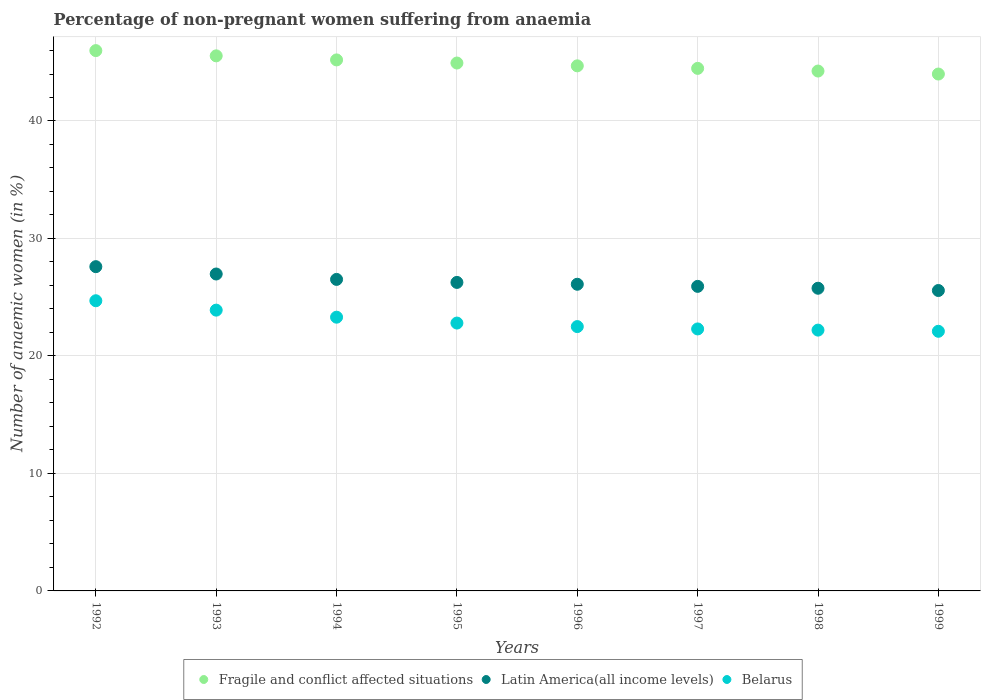Is the number of dotlines equal to the number of legend labels?
Keep it short and to the point. Yes. What is the percentage of non-pregnant women suffering from anaemia in Fragile and conflict affected situations in 1993?
Your response must be concise. 45.54. Across all years, what is the maximum percentage of non-pregnant women suffering from anaemia in Latin America(all income levels)?
Your response must be concise. 27.6. Across all years, what is the minimum percentage of non-pregnant women suffering from anaemia in Belarus?
Offer a terse response. 22.1. In which year was the percentage of non-pregnant women suffering from anaemia in Latin America(all income levels) maximum?
Ensure brevity in your answer.  1992. What is the total percentage of non-pregnant women suffering from anaemia in Latin America(all income levels) in the graph?
Give a very brief answer. 210.71. What is the difference between the percentage of non-pregnant women suffering from anaemia in Belarus in 1997 and that in 1999?
Make the answer very short. 0.2. What is the difference between the percentage of non-pregnant women suffering from anaemia in Belarus in 1998 and the percentage of non-pregnant women suffering from anaemia in Fragile and conflict affected situations in 1996?
Your response must be concise. -22.49. What is the average percentage of non-pregnant women suffering from anaemia in Latin America(all income levels) per year?
Offer a very short reply. 26.34. In the year 1998, what is the difference between the percentage of non-pregnant women suffering from anaemia in Belarus and percentage of non-pregnant women suffering from anaemia in Fragile and conflict affected situations?
Provide a succinct answer. -22.05. What is the ratio of the percentage of non-pregnant women suffering from anaemia in Latin America(all income levels) in 1993 to that in 1996?
Keep it short and to the point. 1.03. Is the percentage of non-pregnant women suffering from anaemia in Fragile and conflict affected situations in 1993 less than that in 1997?
Your answer should be compact. No. What is the difference between the highest and the second highest percentage of non-pregnant women suffering from anaemia in Belarus?
Keep it short and to the point. 0.8. What is the difference between the highest and the lowest percentage of non-pregnant women suffering from anaemia in Belarus?
Keep it short and to the point. 2.6. Is the sum of the percentage of non-pregnant women suffering from anaemia in Belarus in 1992 and 1996 greater than the maximum percentage of non-pregnant women suffering from anaemia in Fragile and conflict affected situations across all years?
Provide a succinct answer. Yes. Is it the case that in every year, the sum of the percentage of non-pregnant women suffering from anaemia in Belarus and percentage of non-pregnant women suffering from anaemia in Fragile and conflict affected situations  is greater than the percentage of non-pregnant women suffering from anaemia in Latin America(all income levels)?
Ensure brevity in your answer.  Yes. Is the percentage of non-pregnant women suffering from anaemia in Belarus strictly less than the percentage of non-pregnant women suffering from anaemia in Fragile and conflict affected situations over the years?
Make the answer very short. Yes. How many dotlines are there?
Make the answer very short. 3. How many years are there in the graph?
Keep it short and to the point. 8. What is the difference between two consecutive major ticks on the Y-axis?
Your answer should be very brief. 10. Does the graph contain any zero values?
Keep it short and to the point. No. Does the graph contain grids?
Give a very brief answer. Yes. Where does the legend appear in the graph?
Make the answer very short. Bottom center. How many legend labels are there?
Provide a succinct answer. 3. What is the title of the graph?
Ensure brevity in your answer.  Percentage of non-pregnant women suffering from anaemia. What is the label or title of the Y-axis?
Your answer should be compact. Number of anaemic women (in %). What is the Number of anaemic women (in %) in Fragile and conflict affected situations in 1992?
Offer a very short reply. 45.99. What is the Number of anaemic women (in %) of Latin America(all income levels) in 1992?
Keep it short and to the point. 27.6. What is the Number of anaemic women (in %) of Belarus in 1992?
Your answer should be very brief. 24.7. What is the Number of anaemic women (in %) of Fragile and conflict affected situations in 1993?
Offer a terse response. 45.54. What is the Number of anaemic women (in %) in Latin America(all income levels) in 1993?
Provide a succinct answer. 26.98. What is the Number of anaemic women (in %) of Belarus in 1993?
Offer a terse response. 23.9. What is the Number of anaemic women (in %) of Fragile and conflict affected situations in 1994?
Provide a short and direct response. 45.2. What is the Number of anaemic women (in %) of Latin America(all income levels) in 1994?
Give a very brief answer. 26.52. What is the Number of anaemic women (in %) in Belarus in 1994?
Provide a succinct answer. 23.3. What is the Number of anaemic women (in %) in Fragile and conflict affected situations in 1995?
Make the answer very short. 44.93. What is the Number of anaemic women (in %) in Latin America(all income levels) in 1995?
Give a very brief answer. 26.26. What is the Number of anaemic women (in %) in Belarus in 1995?
Keep it short and to the point. 22.8. What is the Number of anaemic women (in %) of Fragile and conflict affected situations in 1996?
Ensure brevity in your answer.  44.69. What is the Number of anaemic women (in %) in Latin America(all income levels) in 1996?
Your response must be concise. 26.1. What is the Number of anaemic women (in %) of Belarus in 1996?
Your response must be concise. 22.5. What is the Number of anaemic women (in %) in Fragile and conflict affected situations in 1997?
Ensure brevity in your answer.  44.48. What is the Number of anaemic women (in %) of Latin America(all income levels) in 1997?
Your answer should be compact. 25.92. What is the Number of anaemic women (in %) in Belarus in 1997?
Your response must be concise. 22.3. What is the Number of anaemic women (in %) in Fragile and conflict affected situations in 1998?
Your answer should be compact. 44.25. What is the Number of anaemic women (in %) in Latin America(all income levels) in 1998?
Offer a very short reply. 25.76. What is the Number of anaemic women (in %) of Fragile and conflict affected situations in 1999?
Offer a very short reply. 44. What is the Number of anaemic women (in %) of Latin America(all income levels) in 1999?
Make the answer very short. 25.57. What is the Number of anaemic women (in %) of Belarus in 1999?
Make the answer very short. 22.1. Across all years, what is the maximum Number of anaemic women (in %) in Fragile and conflict affected situations?
Your answer should be very brief. 45.99. Across all years, what is the maximum Number of anaemic women (in %) in Latin America(all income levels)?
Offer a very short reply. 27.6. Across all years, what is the maximum Number of anaemic women (in %) of Belarus?
Provide a succinct answer. 24.7. Across all years, what is the minimum Number of anaemic women (in %) of Fragile and conflict affected situations?
Provide a succinct answer. 44. Across all years, what is the minimum Number of anaemic women (in %) in Latin America(all income levels)?
Make the answer very short. 25.57. Across all years, what is the minimum Number of anaemic women (in %) of Belarus?
Provide a short and direct response. 22.1. What is the total Number of anaemic women (in %) in Fragile and conflict affected situations in the graph?
Your answer should be very brief. 359.09. What is the total Number of anaemic women (in %) of Latin America(all income levels) in the graph?
Provide a short and direct response. 210.71. What is the total Number of anaemic women (in %) in Belarus in the graph?
Provide a succinct answer. 183.8. What is the difference between the Number of anaemic women (in %) of Fragile and conflict affected situations in 1992 and that in 1993?
Offer a terse response. 0.45. What is the difference between the Number of anaemic women (in %) of Latin America(all income levels) in 1992 and that in 1993?
Offer a terse response. 0.63. What is the difference between the Number of anaemic women (in %) in Fragile and conflict affected situations in 1992 and that in 1994?
Give a very brief answer. 0.79. What is the difference between the Number of anaemic women (in %) in Latin America(all income levels) in 1992 and that in 1994?
Your response must be concise. 1.08. What is the difference between the Number of anaemic women (in %) of Belarus in 1992 and that in 1994?
Offer a terse response. 1.4. What is the difference between the Number of anaemic women (in %) in Fragile and conflict affected situations in 1992 and that in 1995?
Ensure brevity in your answer.  1.06. What is the difference between the Number of anaemic women (in %) of Latin America(all income levels) in 1992 and that in 1995?
Your answer should be very brief. 1.34. What is the difference between the Number of anaemic women (in %) of Fragile and conflict affected situations in 1992 and that in 1996?
Provide a short and direct response. 1.3. What is the difference between the Number of anaemic women (in %) in Latin America(all income levels) in 1992 and that in 1996?
Provide a succinct answer. 1.5. What is the difference between the Number of anaemic women (in %) of Belarus in 1992 and that in 1996?
Offer a terse response. 2.2. What is the difference between the Number of anaemic women (in %) of Fragile and conflict affected situations in 1992 and that in 1997?
Ensure brevity in your answer.  1.51. What is the difference between the Number of anaemic women (in %) in Latin America(all income levels) in 1992 and that in 1997?
Ensure brevity in your answer.  1.68. What is the difference between the Number of anaemic women (in %) of Belarus in 1992 and that in 1997?
Keep it short and to the point. 2.4. What is the difference between the Number of anaemic women (in %) in Fragile and conflict affected situations in 1992 and that in 1998?
Your answer should be compact. 1.74. What is the difference between the Number of anaemic women (in %) in Latin America(all income levels) in 1992 and that in 1998?
Give a very brief answer. 1.84. What is the difference between the Number of anaemic women (in %) in Fragile and conflict affected situations in 1992 and that in 1999?
Provide a short and direct response. 1.99. What is the difference between the Number of anaemic women (in %) in Latin America(all income levels) in 1992 and that in 1999?
Your response must be concise. 2.03. What is the difference between the Number of anaemic women (in %) of Belarus in 1992 and that in 1999?
Give a very brief answer. 2.6. What is the difference between the Number of anaemic women (in %) of Fragile and conflict affected situations in 1993 and that in 1994?
Ensure brevity in your answer.  0.35. What is the difference between the Number of anaemic women (in %) in Latin America(all income levels) in 1993 and that in 1994?
Your response must be concise. 0.46. What is the difference between the Number of anaemic women (in %) of Fragile and conflict affected situations in 1993 and that in 1995?
Make the answer very short. 0.61. What is the difference between the Number of anaemic women (in %) in Latin America(all income levels) in 1993 and that in 1995?
Keep it short and to the point. 0.72. What is the difference between the Number of anaemic women (in %) in Fragile and conflict affected situations in 1993 and that in 1996?
Keep it short and to the point. 0.85. What is the difference between the Number of anaemic women (in %) in Latin America(all income levels) in 1993 and that in 1996?
Ensure brevity in your answer.  0.87. What is the difference between the Number of anaemic women (in %) in Fragile and conflict affected situations in 1993 and that in 1997?
Ensure brevity in your answer.  1.07. What is the difference between the Number of anaemic women (in %) in Latin America(all income levels) in 1993 and that in 1997?
Provide a succinct answer. 1.05. What is the difference between the Number of anaemic women (in %) of Belarus in 1993 and that in 1997?
Your answer should be very brief. 1.6. What is the difference between the Number of anaemic women (in %) in Fragile and conflict affected situations in 1993 and that in 1998?
Keep it short and to the point. 1.29. What is the difference between the Number of anaemic women (in %) of Latin America(all income levels) in 1993 and that in 1998?
Keep it short and to the point. 1.21. What is the difference between the Number of anaemic women (in %) of Fragile and conflict affected situations in 1993 and that in 1999?
Your answer should be compact. 1.55. What is the difference between the Number of anaemic women (in %) in Latin America(all income levels) in 1993 and that in 1999?
Your answer should be compact. 1.41. What is the difference between the Number of anaemic women (in %) of Belarus in 1993 and that in 1999?
Your response must be concise. 1.8. What is the difference between the Number of anaemic women (in %) in Fragile and conflict affected situations in 1994 and that in 1995?
Keep it short and to the point. 0.27. What is the difference between the Number of anaemic women (in %) in Latin America(all income levels) in 1994 and that in 1995?
Your answer should be very brief. 0.26. What is the difference between the Number of anaemic women (in %) of Belarus in 1994 and that in 1995?
Offer a very short reply. 0.5. What is the difference between the Number of anaemic women (in %) in Fragile and conflict affected situations in 1994 and that in 1996?
Keep it short and to the point. 0.51. What is the difference between the Number of anaemic women (in %) of Latin America(all income levels) in 1994 and that in 1996?
Your answer should be compact. 0.41. What is the difference between the Number of anaemic women (in %) in Fragile and conflict affected situations in 1994 and that in 1997?
Keep it short and to the point. 0.72. What is the difference between the Number of anaemic women (in %) of Latin America(all income levels) in 1994 and that in 1997?
Your answer should be compact. 0.59. What is the difference between the Number of anaemic women (in %) in Fragile and conflict affected situations in 1994 and that in 1998?
Your answer should be compact. 0.95. What is the difference between the Number of anaemic women (in %) of Latin America(all income levels) in 1994 and that in 1998?
Provide a short and direct response. 0.75. What is the difference between the Number of anaemic women (in %) of Fragile and conflict affected situations in 1994 and that in 1999?
Your response must be concise. 1.2. What is the difference between the Number of anaemic women (in %) of Latin America(all income levels) in 1994 and that in 1999?
Give a very brief answer. 0.95. What is the difference between the Number of anaemic women (in %) in Belarus in 1994 and that in 1999?
Provide a short and direct response. 1.2. What is the difference between the Number of anaemic women (in %) of Fragile and conflict affected situations in 1995 and that in 1996?
Make the answer very short. 0.24. What is the difference between the Number of anaemic women (in %) of Latin America(all income levels) in 1995 and that in 1996?
Offer a very short reply. 0.16. What is the difference between the Number of anaemic women (in %) of Belarus in 1995 and that in 1996?
Offer a very short reply. 0.3. What is the difference between the Number of anaemic women (in %) of Fragile and conflict affected situations in 1995 and that in 1997?
Your answer should be very brief. 0.45. What is the difference between the Number of anaemic women (in %) of Latin America(all income levels) in 1995 and that in 1997?
Offer a very short reply. 0.34. What is the difference between the Number of anaemic women (in %) in Belarus in 1995 and that in 1997?
Provide a succinct answer. 0.5. What is the difference between the Number of anaemic women (in %) in Fragile and conflict affected situations in 1995 and that in 1998?
Your answer should be compact. 0.68. What is the difference between the Number of anaemic women (in %) of Latin America(all income levels) in 1995 and that in 1998?
Your response must be concise. 0.5. What is the difference between the Number of anaemic women (in %) of Belarus in 1995 and that in 1998?
Offer a terse response. 0.6. What is the difference between the Number of anaemic women (in %) of Fragile and conflict affected situations in 1995 and that in 1999?
Make the answer very short. 0.94. What is the difference between the Number of anaemic women (in %) of Latin America(all income levels) in 1995 and that in 1999?
Your response must be concise. 0.69. What is the difference between the Number of anaemic women (in %) of Belarus in 1995 and that in 1999?
Offer a terse response. 0.7. What is the difference between the Number of anaemic women (in %) in Fragile and conflict affected situations in 1996 and that in 1997?
Keep it short and to the point. 0.21. What is the difference between the Number of anaemic women (in %) in Latin America(all income levels) in 1996 and that in 1997?
Make the answer very short. 0.18. What is the difference between the Number of anaemic women (in %) in Belarus in 1996 and that in 1997?
Provide a short and direct response. 0.2. What is the difference between the Number of anaemic women (in %) in Fragile and conflict affected situations in 1996 and that in 1998?
Give a very brief answer. 0.44. What is the difference between the Number of anaemic women (in %) of Latin America(all income levels) in 1996 and that in 1998?
Ensure brevity in your answer.  0.34. What is the difference between the Number of anaemic women (in %) in Belarus in 1996 and that in 1998?
Provide a succinct answer. 0.3. What is the difference between the Number of anaemic women (in %) in Fragile and conflict affected situations in 1996 and that in 1999?
Keep it short and to the point. 0.7. What is the difference between the Number of anaemic women (in %) in Latin America(all income levels) in 1996 and that in 1999?
Your answer should be very brief. 0.53. What is the difference between the Number of anaemic women (in %) in Fragile and conflict affected situations in 1997 and that in 1998?
Ensure brevity in your answer.  0.23. What is the difference between the Number of anaemic women (in %) of Latin America(all income levels) in 1997 and that in 1998?
Your response must be concise. 0.16. What is the difference between the Number of anaemic women (in %) of Fragile and conflict affected situations in 1997 and that in 1999?
Ensure brevity in your answer.  0.48. What is the difference between the Number of anaemic women (in %) of Latin America(all income levels) in 1997 and that in 1999?
Make the answer very short. 0.35. What is the difference between the Number of anaemic women (in %) in Fragile and conflict affected situations in 1998 and that in 1999?
Keep it short and to the point. 0.25. What is the difference between the Number of anaemic women (in %) in Latin America(all income levels) in 1998 and that in 1999?
Ensure brevity in your answer.  0.19. What is the difference between the Number of anaemic women (in %) in Belarus in 1998 and that in 1999?
Provide a short and direct response. 0.1. What is the difference between the Number of anaemic women (in %) in Fragile and conflict affected situations in 1992 and the Number of anaemic women (in %) in Latin America(all income levels) in 1993?
Offer a very short reply. 19.02. What is the difference between the Number of anaemic women (in %) of Fragile and conflict affected situations in 1992 and the Number of anaemic women (in %) of Belarus in 1993?
Offer a terse response. 22.09. What is the difference between the Number of anaemic women (in %) of Latin America(all income levels) in 1992 and the Number of anaemic women (in %) of Belarus in 1993?
Your answer should be compact. 3.7. What is the difference between the Number of anaemic women (in %) in Fragile and conflict affected situations in 1992 and the Number of anaemic women (in %) in Latin America(all income levels) in 1994?
Provide a short and direct response. 19.47. What is the difference between the Number of anaemic women (in %) in Fragile and conflict affected situations in 1992 and the Number of anaemic women (in %) in Belarus in 1994?
Your response must be concise. 22.69. What is the difference between the Number of anaemic women (in %) of Latin America(all income levels) in 1992 and the Number of anaemic women (in %) of Belarus in 1994?
Ensure brevity in your answer.  4.3. What is the difference between the Number of anaemic women (in %) of Fragile and conflict affected situations in 1992 and the Number of anaemic women (in %) of Latin America(all income levels) in 1995?
Your answer should be compact. 19.73. What is the difference between the Number of anaemic women (in %) of Fragile and conflict affected situations in 1992 and the Number of anaemic women (in %) of Belarus in 1995?
Make the answer very short. 23.19. What is the difference between the Number of anaemic women (in %) of Latin America(all income levels) in 1992 and the Number of anaemic women (in %) of Belarus in 1995?
Keep it short and to the point. 4.8. What is the difference between the Number of anaemic women (in %) in Fragile and conflict affected situations in 1992 and the Number of anaemic women (in %) in Latin America(all income levels) in 1996?
Make the answer very short. 19.89. What is the difference between the Number of anaemic women (in %) in Fragile and conflict affected situations in 1992 and the Number of anaemic women (in %) in Belarus in 1996?
Give a very brief answer. 23.49. What is the difference between the Number of anaemic women (in %) of Latin America(all income levels) in 1992 and the Number of anaemic women (in %) of Belarus in 1996?
Your response must be concise. 5.1. What is the difference between the Number of anaemic women (in %) of Fragile and conflict affected situations in 1992 and the Number of anaemic women (in %) of Latin America(all income levels) in 1997?
Make the answer very short. 20.07. What is the difference between the Number of anaemic women (in %) in Fragile and conflict affected situations in 1992 and the Number of anaemic women (in %) in Belarus in 1997?
Keep it short and to the point. 23.69. What is the difference between the Number of anaemic women (in %) in Latin America(all income levels) in 1992 and the Number of anaemic women (in %) in Belarus in 1997?
Give a very brief answer. 5.3. What is the difference between the Number of anaemic women (in %) of Fragile and conflict affected situations in 1992 and the Number of anaemic women (in %) of Latin America(all income levels) in 1998?
Your answer should be compact. 20.23. What is the difference between the Number of anaemic women (in %) in Fragile and conflict affected situations in 1992 and the Number of anaemic women (in %) in Belarus in 1998?
Keep it short and to the point. 23.79. What is the difference between the Number of anaemic women (in %) in Latin America(all income levels) in 1992 and the Number of anaemic women (in %) in Belarus in 1998?
Offer a very short reply. 5.4. What is the difference between the Number of anaemic women (in %) of Fragile and conflict affected situations in 1992 and the Number of anaemic women (in %) of Latin America(all income levels) in 1999?
Your response must be concise. 20.42. What is the difference between the Number of anaemic women (in %) of Fragile and conflict affected situations in 1992 and the Number of anaemic women (in %) of Belarus in 1999?
Make the answer very short. 23.89. What is the difference between the Number of anaemic women (in %) of Latin America(all income levels) in 1992 and the Number of anaemic women (in %) of Belarus in 1999?
Give a very brief answer. 5.5. What is the difference between the Number of anaemic women (in %) of Fragile and conflict affected situations in 1993 and the Number of anaemic women (in %) of Latin America(all income levels) in 1994?
Keep it short and to the point. 19.03. What is the difference between the Number of anaemic women (in %) in Fragile and conflict affected situations in 1993 and the Number of anaemic women (in %) in Belarus in 1994?
Offer a very short reply. 22.24. What is the difference between the Number of anaemic women (in %) in Latin America(all income levels) in 1993 and the Number of anaemic women (in %) in Belarus in 1994?
Provide a short and direct response. 3.68. What is the difference between the Number of anaemic women (in %) of Fragile and conflict affected situations in 1993 and the Number of anaemic women (in %) of Latin America(all income levels) in 1995?
Keep it short and to the point. 19.29. What is the difference between the Number of anaemic women (in %) in Fragile and conflict affected situations in 1993 and the Number of anaemic women (in %) in Belarus in 1995?
Your answer should be very brief. 22.74. What is the difference between the Number of anaemic women (in %) of Latin America(all income levels) in 1993 and the Number of anaemic women (in %) of Belarus in 1995?
Provide a succinct answer. 4.18. What is the difference between the Number of anaemic women (in %) of Fragile and conflict affected situations in 1993 and the Number of anaemic women (in %) of Latin America(all income levels) in 1996?
Give a very brief answer. 19.44. What is the difference between the Number of anaemic women (in %) of Fragile and conflict affected situations in 1993 and the Number of anaemic women (in %) of Belarus in 1996?
Ensure brevity in your answer.  23.04. What is the difference between the Number of anaemic women (in %) in Latin America(all income levels) in 1993 and the Number of anaemic women (in %) in Belarus in 1996?
Provide a succinct answer. 4.48. What is the difference between the Number of anaemic women (in %) of Fragile and conflict affected situations in 1993 and the Number of anaemic women (in %) of Latin America(all income levels) in 1997?
Offer a very short reply. 19.62. What is the difference between the Number of anaemic women (in %) of Fragile and conflict affected situations in 1993 and the Number of anaemic women (in %) of Belarus in 1997?
Make the answer very short. 23.24. What is the difference between the Number of anaemic women (in %) in Latin America(all income levels) in 1993 and the Number of anaemic women (in %) in Belarus in 1997?
Provide a short and direct response. 4.68. What is the difference between the Number of anaemic women (in %) in Fragile and conflict affected situations in 1993 and the Number of anaemic women (in %) in Latin America(all income levels) in 1998?
Give a very brief answer. 19.78. What is the difference between the Number of anaemic women (in %) in Fragile and conflict affected situations in 1993 and the Number of anaemic women (in %) in Belarus in 1998?
Provide a succinct answer. 23.34. What is the difference between the Number of anaemic women (in %) in Latin America(all income levels) in 1993 and the Number of anaemic women (in %) in Belarus in 1998?
Offer a very short reply. 4.78. What is the difference between the Number of anaemic women (in %) in Fragile and conflict affected situations in 1993 and the Number of anaemic women (in %) in Latin America(all income levels) in 1999?
Your response must be concise. 19.97. What is the difference between the Number of anaemic women (in %) in Fragile and conflict affected situations in 1993 and the Number of anaemic women (in %) in Belarus in 1999?
Provide a succinct answer. 23.44. What is the difference between the Number of anaemic women (in %) of Latin America(all income levels) in 1993 and the Number of anaemic women (in %) of Belarus in 1999?
Ensure brevity in your answer.  4.88. What is the difference between the Number of anaemic women (in %) in Fragile and conflict affected situations in 1994 and the Number of anaemic women (in %) in Latin America(all income levels) in 1995?
Your answer should be very brief. 18.94. What is the difference between the Number of anaemic women (in %) of Fragile and conflict affected situations in 1994 and the Number of anaemic women (in %) of Belarus in 1995?
Make the answer very short. 22.4. What is the difference between the Number of anaemic women (in %) in Latin America(all income levels) in 1994 and the Number of anaemic women (in %) in Belarus in 1995?
Keep it short and to the point. 3.72. What is the difference between the Number of anaemic women (in %) of Fragile and conflict affected situations in 1994 and the Number of anaemic women (in %) of Latin America(all income levels) in 1996?
Give a very brief answer. 19.1. What is the difference between the Number of anaemic women (in %) of Fragile and conflict affected situations in 1994 and the Number of anaemic women (in %) of Belarus in 1996?
Keep it short and to the point. 22.7. What is the difference between the Number of anaemic women (in %) of Latin America(all income levels) in 1994 and the Number of anaemic women (in %) of Belarus in 1996?
Your answer should be very brief. 4.02. What is the difference between the Number of anaemic women (in %) in Fragile and conflict affected situations in 1994 and the Number of anaemic women (in %) in Latin America(all income levels) in 1997?
Offer a very short reply. 19.28. What is the difference between the Number of anaemic women (in %) of Fragile and conflict affected situations in 1994 and the Number of anaemic women (in %) of Belarus in 1997?
Give a very brief answer. 22.9. What is the difference between the Number of anaemic women (in %) of Latin America(all income levels) in 1994 and the Number of anaemic women (in %) of Belarus in 1997?
Offer a very short reply. 4.22. What is the difference between the Number of anaemic women (in %) in Fragile and conflict affected situations in 1994 and the Number of anaemic women (in %) in Latin America(all income levels) in 1998?
Give a very brief answer. 19.44. What is the difference between the Number of anaemic women (in %) of Fragile and conflict affected situations in 1994 and the Number of anaemic women (in %) of Belarus in 1998?
Ensure brevity in your answer.  23. What is the difference between the Number of anaemic women (in %) in Latin America(all income levels) in 1994 and the Number of anaemic women (in %) in Belarus in 1998?
Offer a terse response. 4.32. What is the difference between the Number of anaemic women (in %) of Fragile and conflict affected situations in 1994 and the Number of anaemic women (in %) of Latin America(all income levels) in 1999?
Offer a terse response. 19.63. What is the difference between the Number of anaemic women (in %) of Fragile and conflict affected situations in 1994 and the Number of anaemic women (in %) of Belarus in 1999?
Your answer should be compact. 23.1. What is the difference between the Number of anaemic women (in %) in Latin America(all income levels) in 1994 and the Number of anaemic women (in %) in Belarus in 1999?
Keep it short and to the point. 4.42. What is the difference between the Number of anaemic women (in %) in Fragile and conflict affected situations in 1995 and the Number of anaemic women (in %) in Latin America(all income levels) in 1996?
Offer a very short reply. 18.83. What is the difference between the Number of anaemic women (in %) in Fragile and conflict affected situations in 1995 and the Number of anaemic women (in %) in Belarus in 1996?
Your answer should be very brief. 22.43. What is the difference between the Number of anaemic women (in %) in Latin America(all income levels) in 1995 and the Number of anaemic women (in %) in Belarus in 1996?
Provide a short and direct response. 3.76. What is the difference between the Number of anaemic women (in %) in Fragile and conflict affected situations in 1995 and the Number of anaemic women (in %) in Latin America(all income levels) in 1997?
Your response must be concise. 19.01. What is the difference between the Number of anaemic women (in %) in Fragile and conflict affected situations in 1995 and the Number of anaemic women (in %) in Belarus in 1997?
Your answer should be very brief. 22.63. What is the difference between the Number of anaemic women (in %) of Latin America(all income levels) in 1995 and the Number of anaemic women (in %) of Belarus in 1997?
Ensure brevity in your answer.  3.96. What is the difference between the Number of anaemic women (in %) in Fragile and conflict affected situations in 1995 and the Number of anaemic women (in %) in Latin America(all income levels) in 1998?
Your answer should be very brief. 19.17. What is the difference between the Number of anaemic women (in %) of Fragile and conflict affected situations in 1995 and the Number of anaemic women (in %) of Belarus in 1998?
Offer a very short reply. 22.73. What is the difference between the Number of anaemic women (in %) of Latin America(all income levels) in 1995 and the Number of anaemic women (in %) of Belarus in 1998?
Offer a very short reply. 4.06. What is the difference between the Number of anaemic women (in %) of Fragile and conflict affected situations in 1995 and the Number of anaemic women (in %) of Latin America(all income levels) in 1999?
Your answer should be compact. 19.36. What is the difference between the Number of anaemic women (in %) in Fragile and conflict affected situations in 1995 and the Number of anaemic women (in %) in Belarus in 1999?
Your answer should be very brief. 22.83. What is the difference between the Number of anaemic women (in %) in Latin America(all income levels) in 1995 and the Number of anaemic women (in %) in Belarus in 1999?
Provide a short and direct response. 4.16. What is the difference between the Number of anaemic women (in %) of Fragile and conflict affected situations in 1996 and the Number of anaemic women (in %) of Latin America(all income levels) in 1997?
Provide a succinct answer. 18.77. What is the difference between the Number of anaemic women (in %) in Fragile and conflict affected situations in 1996 and the Number of anaemic women (in %) in Belarus in 1997?
Provide a short and direct response. 22.39. What is the difference between the Number of anaemic women (in %) in Latin America(all income levels) in 1996 and the Number of anaemic women (in %) in Belarus in 1997?
Your response must be concise. 3.8. What is the difference between the Number of anaemic women (in %) of Fragile and conflict affected situations in 1996 and the Number of anaemic women (in %) of Latin America(all income levels) in 1998?
Offer a terse response. 18.93. What is the difference between the Number of anaemic women (in %) of Fragile and conflict affected situations in 1996 and the Number of anaemic women (in %) of Belarus in 1998?
Provide a succinct answer. 22.49. What is the difference between the Number of anaemic women (in %) in Latin America(all income levels) in 1996 and the Number of anaemic women (in %) in Belarus in 1998?
Offer a very short reply. 3.9. What is the difference between the Number of anaemic women (in %) of Fragile and conflict affected situations in 1996 and the Number of anaemic women (in %) of Latin America(all income levels) in 1999?
Your answer should be very brief. 19.12. What is the difference between the Number of anaemic women (in %) in Fragile and conflict affected situations in 1996 and the Number of anaemic women (in %) in Belarus in 1999?
Make the answer very short. 22.59. What is the difference between the Number of anaemic women (in %) in Latin America(all income levels) in 1996 and the Number of anaemic women (in %) in Belarus in 1999?
Give a very brief answer. 4. What is the difference between the Number of anaemic women (in %) of Fragile and conflict affected situations in 1997 and the Number of anaemic women (in %) of Latin America(all income levels) in 1998?
Make the answer very short. 18.72. What is the difference between the Number of anaemic women (in %) of Fragile and conflict affected situations in 1997 and the Number of anaemic women (in %) of Belarus in 1998?
Keep it short and to the point. 22.28. What is the difference between the Number of anaemic women (in %) of Latin America(all income levels) in 1997 and the Number of anaemic women (in %) of Belarus in 1998?
Offer a very short reply. 3.72. What is the difference between the Number of anaemic women (in %) of Fragile and conflict affected situations in 1997 and the Number of anaemic women (in %) of Latin America(all income levels) in 1999?
Your response must be concise. 18.91. What is the difference between the Number of anaemic women (in %) in Fragile and conflict affected situations in 1997 and the Number of anaemic women (in %) in Belarus in 1999?
Provide a short and direct response. 22.38. What is the difference between the Number of anaemic women (in %) of Latin America(all income levels) in 1997 and the Number of anaemic women (in %) of Belarus in 1999?
Your answer should be very brief. 3.82. What is the difference between the Number of anaemic women (in %) in Fragile and conflict affected situations in 1998 and the Number of anaemic women (in %) in Latin America(all income levels) in 1999?
Offer a very short reply. 18.68. What is the difference between the Number of anaemic women (in %) of Fragile and conflict affected situations in 1998 and the Number of anaemic women (in %) of Belarus in 1999?
Ensure brevity in your answer.  22.15. What is the difference between the Number of anaemic women (in %) of Latin America(all income levels) in 1998 and the Number of anaemic women (in %) of Belarus in 1999?
Offer a terse response. 3.66. What is the average Number of anaemic women (in %) in Fragile and conflict affected situations per year?
Provide a short and direct response. 44.89. What is the average Number of anaemic women (in %) of Latin America(all income levels) per year?
Make the answer very short. 26.34. What is the average Number of anaemic women (in %) in Belarus per year?
Provide a short and direct response. 22.98. In the year 1992, what is the difference between the Number of anaemic women (in %) in Fragile and conflict affected situations and Number of anaemic women (in %) in Latin America(all income levels)?
Make the answer very short. 18.39. In the year 1992, what is the difference between the Number of anaemic women (in %) in Fragile and conflict affected situations and Number of anaemic women (in %) in Belarus?
Offer a terse response. 21.29. In the year 1992, what is the difference between the Number of anaemic women (in %) of Latin America(all income levels) and Number of anaemic women (in %) of Belarus?
Your response must be concise. 2.9. In the year 1993, what is the difference between the Number of anaemic women (in %) of Fragile and conflict affected situations and Number of anaemic women (in %) of Latin America(all income levels)?
Keep it short and to the point. 18.57. In the year 1993, what is the difference between the Number of anaemic women (in %) of Fragile and conflict affected situations and Number of anaemic women (in %) of Belarus?
Provide a succinct answer. 21.64. In the year 1993, what is the difference between the Number of anaemic women (in %) of Latin America(all income levels) and Number of anaemic women (in %) of Belarus?
Offer a terse response. 3.08. In the year 1994, what is the difference between the Number of anaemic women (in %) of Fragile and conflict affected situations and Number of anaemic women (in %) of Latin America(all income levels)?
Give a very brief answer. 18.68. In the year 1994, what is the difference between the Number of anaemic women (in %) of Fragile and conflict affected situations and Number of anaemic women (in %) of Belarus?
Your answer should be very brief. 21.9. In the year 1994, what is the difference between the Number of anaemic women (in %) of Latin America(all income levels) and Number of anaemic women (in %) of Belarus?
Keep it short and to the point. 3.22. In the year 1995, what is the difference between the Number of anaemic women (in %) of Fragile and conflict affected situations and Number of anaemic women (in %) of Latin America(all income levels)?
Offer a very short reply. 18.67. In the year 1995, what is the difference between the Number of anaemic women (in %) of Fragile and conflict affected situations and Number of anaemic women (in %) of Belarus?
Give a very brief answer. 22.13. In the year 1995, what is the difference between the Number of anaemic women (in %) of Latin America(all income levels) and Number of anaemic women (in %) of Belarus?
Ensure brevity in your answer.  3.46. In the year 1996, what is the difference between the Number of anaemic women (in %) of Fragile and conflict affected situations and Number of anaemic women (in %) of Latin America(all income levels)?
Ensure brevity in your answer.  18.59. In the year 1996, what is the difference between the Number of anaemic women (in %) in Fragile and conflict affected situations and Number of anaemic women (in %) in Belarus?
Keep it short and to the point. 22.19. In the year 1996, what is the difference between the Number of anaemic women (in %) of Latin America(all income levels) and Number of anaemic women (in %) of Belarus?
Make the answer very short. 3.6. In the year 1997, what is the difference between the Number of anaemic women (in %) of Fragile and conflict affected situations and Number of anaemic women (in %) of Latin America(all income levels)?
Your answer should be very brief. 18.56. In the year 1997, what is the difference between the Number of anaemic women (in %) in Fragile and conflict affected situations and Number of anaemic women (in %) in Belarus?
Give a very brief answer. 22.18. In the year 1997, what is the difference between the Number of anaemic women (in %) in Latin America(all income levels) and Number of anaemic women (in %) in Belarus?
Make the answer very short. 3.62. In the year 1998, what is the difference between the Number of anaemic women (in %) of Fragile and conflict affected situations and Number of anaemic women (in %) of Latin America(all income levels)?
Ensure brevity in your answer.  18.49. In the year 1998, what is the difference between the Number of anaemic women (in %) in Fragile and conflict affected situations and Number of anaemic women (in %) in Belarus?
Your response must be concise. 22.05. In the year 1998, what is the difference between the Number of anaemic women (in %) in Latin America(all income levels) and Number of anaemic women (in %) in Belarus?
Your answer should be compact. 3.56. In the year 1999, what is the difference between the Number of anaemic women (in %) in Fragile and conflict affected situations and Number of anaemic women (in %) in Latin America(all income levels)?
Provide a succinct answer. 18.43. In the year 1999, what is the difference between the Number of anaemic women (in %) of Fragile and conflict affected situations and Number of anaemic women (in %) of Belarus?
Your answer should be compact. 21.9. In the year 1999, what is the difference between the Number of anaemic women (in %) of Latin America(all income levels) and Number of anaemic women (in %) of Belarus?
Give a very brief answer. 3.47. What is the ratio of the Number of anaemic women (in %) in Fragile and conflict affected situations in 1992 to that in 1993?
Keep it short and to the point. 1.01. What is the ratio of the Number of anaemic women (in %) in Latin America(all income levels) in 1992 to that in 1993?
Your answer should be very brief. 1.02. What is the ratio of the Number of anaemic women (in %) in Belarus in 1992 to that in 1993?
Provide a short and direct response. 1.03. What is the ratio of the Number of anaemic women (in %) of Fragile and conflict affected situations in 1992 to that in 1994?
Your answer should be compact. 1.02. What is the ratio of the Number of anaemic women (in %) in Latin America(all income levels) in 1992 to that in 1994?
Make the answer very short. 1.04. What is the ratio of the Number of anaemic women (in %) of Belarus in 1992 to that in 1994?
Your answer should be very brief. 1.06. What is the ratio of the Number of anaemic women (in %) of Fragile and conflict affected situations in 1992 to that in 1995?
Provide a succinct answer. 1.02. What is the ratio of the Number of anaemic women (in %) of Latin America(all income levels) in 1992 to that in 1995?
Give a very brief answer. 1.05. What is the ratio of the Number of anaemic women (in %) of Fragile and conflict affected situations in 1992 to that in 1996?
Your response must be concise. 1.03. What is the ratio of the Number of anaemic women (in %) in Latin America(all income levels) in 1992 to that in 1996?
Provide a succinct answer. 1.06. What is the ratio of the Number of anaemic women (in %) of Belarus in 1992 to that in 1996?
Give a very brief answer. 1.1. What is the ratio of the Number of anaemic women (in %) of Fragile and conflict affected situations in 1992 to that in 1997?
Give a very brief answer. 1.03. What is the ratio of the Number of anaemic women (in %) of Latin America(all income levels) in 1992 to that in 1997?
Offer a very short reply. 1.06. What is the ratio of the Number of anaemic women (in %) in Belarus in 1992 to that in 1997?
Provide a succinct answer. 1.11. What is the ratio of the Number of anaemic women (in %) of Fragile and conflict affected situations in 1992 to that in 1998?
Give a very brief answer. 1.04. What is the ratio of the Number of anaemic women (in %) of Latin America(all income levels) in 1992 to that in 1998?
Keep it short and to the point. 1.07. What is the ratio of the Number of anaemic women (in %) of Belarus in 1992 to that in 1998?
Your answer should be compact. 1.11. What is the ratio of the Number of anaemic women (in %) in Fragile and conflict affected situations in 1992 to that in 1999?
Give a very brief answer. 1.05. What is the ratio of the Number of anaemic women (in %) of Latin America(all income levels) in 1992 to that in 1999?
Make the answer very short. 1.08. What is the ratio of the Number of anaemic women (in %) of Belarus in 1992 to that in 1999?
Give a very brief answer. 1.12. What is the ratio of the Number of anaemic women (in %) of Fragile and conflict affected situations in 1993 to that in 1994?
Provide a short and direct response. 1.01. What is the ratio of the Number of anaemic women (in %) of Latin America(all income levels) in 1993 to that in 1994?
Your response must be concise. 1.02. What is the ratio of the Number of anaemic women (in %) of Belarus in 1993 to that in 1994?
Your answer should be compact. 1.03. What is the ratio of the Number of anaemic women (in %) in Fragile and conflict affected situations in 1993 to that in 1995?
Keep it short and to the point. 1.01. What is the ratio of the Number of anaemic women (in %) in Latin America(all income levels) in 1993 to that in 1995?
Keep it short and to the point. 1.03. What is the ratio of the Number of anaemic women (in %) of Belarus in 1993 to that in 1995?
Ensure brevity in your answer.  1.05. What is the ratio of the Number of anaemic women (in %) in Latin America(all income levels) in 1993 to that in 1996?
Ensure brevity in your answer.  1.03. What is the ratio of the Number of anaemic women (in %) in Belarus in 1993 to that in 1996?
Ensure brevity in your answer.  1.06. What is the ratio of the Number of anaemic women (in %) in Latin America(all income levels) in 1993 to that in 1997?
Ensure brevity in your answer.  1.04. What is the ratio of the Number of anaemic women (in %) of Belarus in 1993 to that in 1997?
Your answer should be compact. 1.07. What is the ratio of the Number of anaemic women (in %) in Fragile and conflict affected situations in 1993 to that in 1998?
Provide a short and direct response. 1.03. What is the ratio of the Number of anaemic women (in %) in Latin America(all income levels) in 1993 to that in 1998?
Provide a succinct answer. 1.05. What is the ratio of the Number of anaemic women (in %) of Belarus in 1993 to that in 1998?
Offer a terse response. 1.08. What is the ratio of the Number of anaemic women (in %) of Fragile and conflict affected situations in 1993 to that in 1999?
Your answer should be very brief. 1.04. What is the ratio of the Number of anaemic women (in %) in Latin America(all income levels) in 1993 to that in 1999?
Your response must be concise. 1.05. What is the ratio of the Number of anaemic women (in %) of Belarus in 1993 to that in 1999?
Give a very brief answer. 1.08. What is the ratio of the Number of anaemic women (in %) in Fragile and conflict affected situations in 1994 to that in 1995?
Ensure brevity in your answer.  1.01. What is the ratio of the Number of anaemic women (in %) of Latin America(all income levels) in 1994 to that in 1995?
Offer a terse response. 1.01. What is the ratio of the Number of anaemic women (in %) in Belarus in 1994 to that in 1995?
Provide a succinct answer. 1.02. What is the ratio of the Number of anaemic women (in %) of Fragile and conflict affected situations in 1994 to that in 1996?
Provide a short and direct response. 1.01. What is the ratio of the Number of anaemic women (in %) in Latin America(all income levels) in 1994 to that in 1996?
Your response must be concise. 1.02. What is the ratio of the Number of anaemic women (in %) of Belarus in 1994 to that in 1996?
Provide a short and direct response. 1.04. What is the ratio of the Number of anaemic women (in %) of Fragile and conflict affected situations in 1994 to that in 1997?
Give a very brief answer. 1.02. What is the ratio of the Number of anaemic women (in %) of Latin America(all income levels) in 1994 to that in 1997?
Offer a terse response. 1.02. What is the ratio of the Number of anaemic women (in %) in Belarus in 1994 to that in 1997?
Give a very brief answer. 1.04. What is the ratio of the Number of anaemic women (in %) in Fragile and conflict affected situations in 1994 to that in 1998?
Offer a terse response. 1.02. What is the ratio of the Number of anaemic women (in %) of Latin America(all income levels) in 1994 to that in 1998?
Provide a succinct answer. 1.03. What is the ratio of the Number of anaemic women (in %) in Belarus in 1994 to that in 1998?
Offer a very short reply. 1.05. What is the ratio of the Number of anaemic women (in %) in Fragile and conflict affected situations in 1994 to that in 1999?
Provide a succinct answer. 1.03. What is the ratio of the Number of anaemic women (in %) of Latin America(all income levels) in 1994 to that in 1999?
Make the answer very short. 1.04. What is the ratio of the Number of anaemic women (in %) in Belarus in 1994 to that in 1999?
Keep it short and to the point. 1.05. What is the ratio of the Number of anaemic women (in %) in Fragile and conflict affected situations in 1995 to that in 1996?
Keep it short and to the point. 1.01. What is the ratio of the Number of anaemic women (in %) of Latin America(all income levels) in 1995 to that in 1996?
Your answer should be compact. 1.01. What is the ratio of the Number of anaemic women (in %) in Belarus in 1995 to that in 1996?
Offer a very short reply. 1.01. What is the ratio of the Number of anaemic women (in %) of Fragile and conflict affected situations in 1995 to that in 1997?
Offer a very short reply. 1.01. What is the ratio of the Number of anaemic women (in %) in Latin America(all income levels) in 1995 to that in 1997?
Keep it short and to the point. 1.01. What is the ratio of the Number of anaemic women (in %) in Belarus in 1995 to that in 1997?
Give a very brief answer. 1.02. What is the ratio of the Number of anaemic women (in %) in Fragile and conflict affected situations in 1995 to that in 1998?
Give a very brief answer. 1.02. What is the ratio of the Number of anaemic women (in %) of Latin America(all income levels) in 1995 to that in 1998?
Offer a terse response. 1.02. What is the ratio of the Number of anaemic women (in %) in Belarus in 1995 to that in 1998?
Your response must be concise. 1.03. What is the ratio of the Number of anaemic women (in %) in Fragile and conflict affected situations in 1995 to that in 1999?
Give a very brief answer. 1.02. What is the ratio of the Number of anaemic women (in %) in Latin America(all income levels) in 1995 to that in 1999?
Offer a very short reply. 1.03. What is the ratio of the Number of anaemic women (in %) in Belarus in 1995 to that in 1999?
Your answer should be compact. 1.03. What is the ratio of the Number of anaemic women (in %) in Fragile and conflict affected situations in 1996 to that in 1997?
Make the answer very short. 1. What is the ratio of the Number of anaemic women (in %) of Latin America(all income levels) in 1996 to that in 1997?
Offer a very short reply. 1.01. What is the ratio of the Number of anaemic women (in %) of Fragile and conflict affected situations in 1996 to that in 1998?
Your answer should be very brief. 1.01. What is the ratio of the Number of anaemic women (in %) in Latin America(all income levels) in 1996 to that in 1998?
Give a very brief answer. 1.01. What is the ratio of the Number of anaemic women (in %) of Belarus in 1996 to that in 1998?
Your response must be concise. 1.01. What is the ratio of the Number of anaemic women (in %) of Fragile and conflict affected situations in 1996 to that in 1999?
Your answer should be very brief. 1.02. What is the ratio of the Number of anaemic women (in %) in Latin America(all income levels) in 1996 to that in 1999?
Your answer should be compact. 1.02. What is the ratio of the Number of anaemic women (in %) in Belarus in 1996 to that in 1999?
Offer a very short reply. 1.02. What is the ratio of the Number of anaemic women (in %) of Fragile and conflict affected situations in 1997 to that in 1999?
Your answer should be very brief. 1.01. What is the ratio of the Number of anaemic women (in %) in Latin America(all income levels) in 1997 to that in 1999?
Your answer should be very brief. 1.01. What is the ratio of the Number of anaemic women (in %) in Belarus in 1997 to that in 1999?
Ensure brevity in your answer.  1.01. What is the ratio of the Number of anaemic women (in %) of Fragile and conflict affected situations in 1998 to that in 1999?
Offer a terse response. 1.01. What is the ratio of the Number of anaemic women (in %) of Latin America(all income levels) in 1998 to that in 1999?
Your answer should be very brief. 1.01. What is the difference between the highest and the second highest Number of anaemic women (in %) of Fragile and conflict affected situations?
Your response must be concise. 0.45. What is the difference between the highest and the second highest Number of anaemic women (in %) in Latin America(all income levels)?
Give a very brief answer. 0.63. What is the difference between the highest and the second highest Number of anaemic women (in %) of Belarus?
Offer a terse response. 0.8. What is the difference between the highest and the lowest Number of anaemic women (in %) in Fragile and conflict affected situations?
Your answer should be compact. 1.99. What is the difference between the highest and the lowest Number of anaemic women (in %) of Latin America(all income levels)?
Offer a terse response. 2.03. 